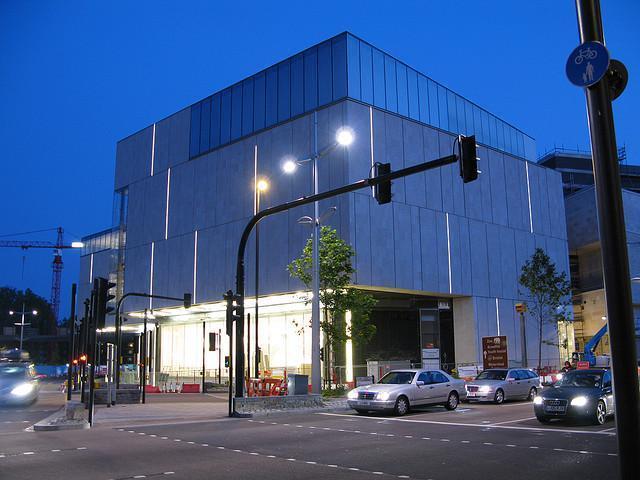How many cars are visible in this picture?
Give a very brief answer. 4. How many cars are there?
Give a very brief answer. 3. How many cows do you see?
Give a very brief answer. 0. 